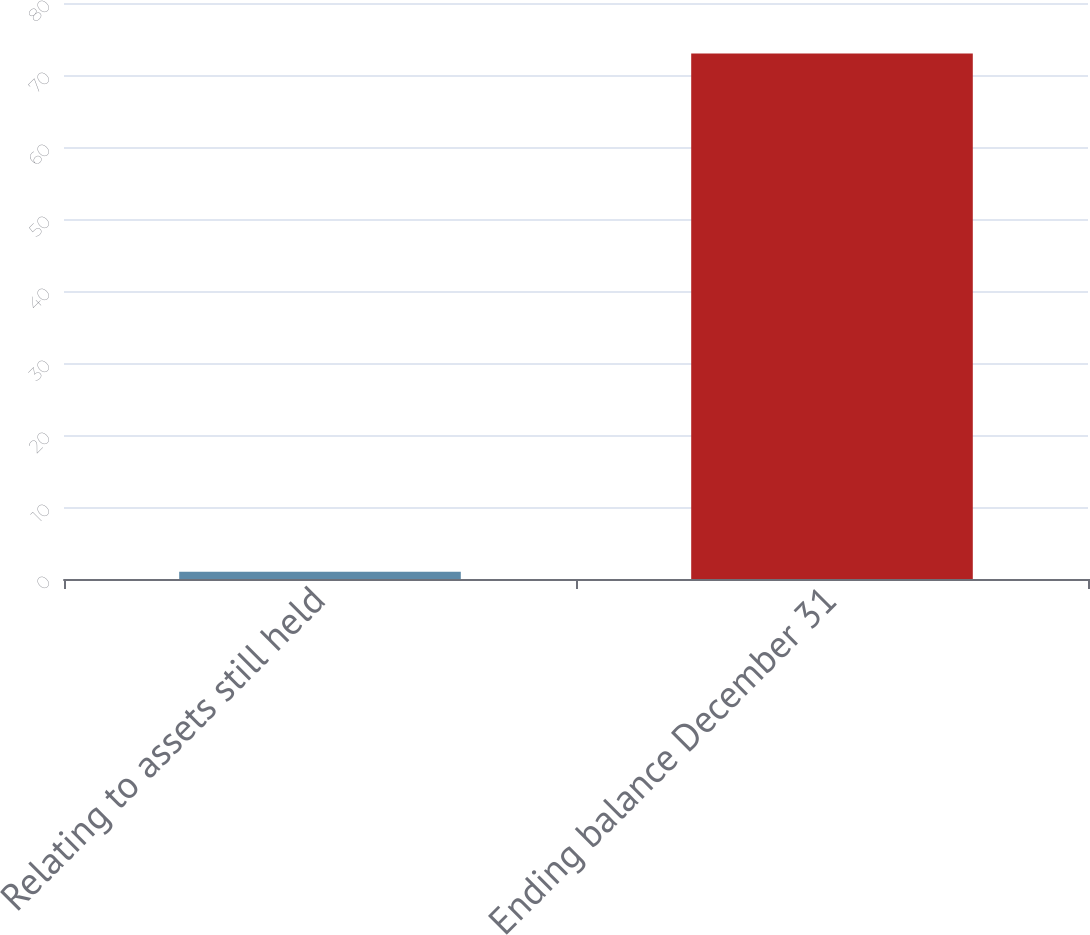<chart> <loc_0><loc_0><loc_500><loc_500><bar_chart><fcel>Relating to assets still held<fcel>Ending balance December 31<nl><fcel>1<fcel>73<nl></chart> 